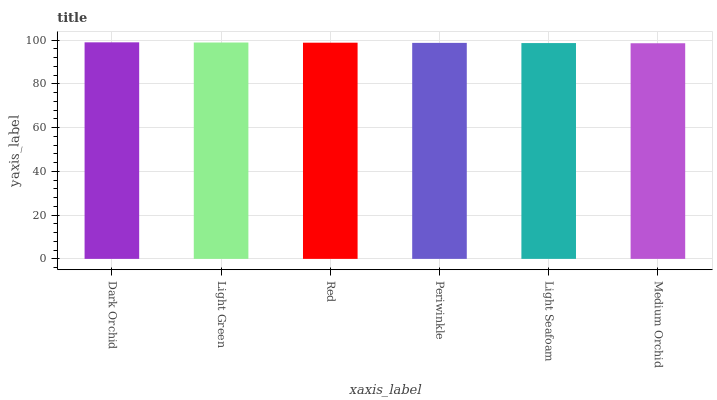Is Medium Orchid the minimum?
Answer yes or no. Yes. Is Dark Orchid the maximum?
Answer yes or no. Yes. Is Light Green the minimum?
Answer yes or no. No. Is Light Green the maximum?
Answer yes or no. No. Is Dark Orchid greater than Light Green?
Answer yes or no. Yes. Is Light Green less than Dark Orchid?
Answer yes or no. Yes. Is Light Green greater than Dark Orchid?
Answer yes or no. No. Is Dark Orchid less than Light Green?
Answer yes or no. No. Is Red the high median?
Answer yes or no. Yes. Is Periwinkle the low median?
Answer yes or no. Yes. Is Periwinkle the high median?
Answer yes or no. No. Is Medium Orchid the low median?
Answer yes or no. No. 